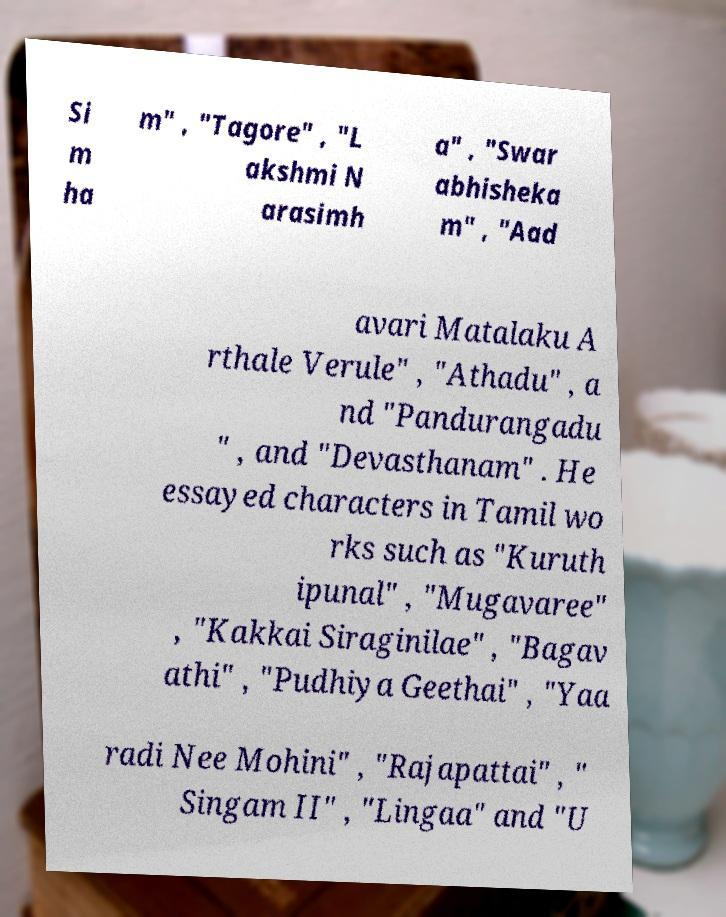I need the written content from this picture converted into text. Can you do that? Si m ha m" , "Tagore" , "L akshmi N arasimh a" , "Swar abhisheka m" , "Aad avari Matalaku A rthale Verule" , "Athadu" , a nd "Pandurangadu " , and "Devasthanam" . He essayed characters in Tamil wo rks such as "Kuruth ipunal" , "Mugavaree" , "Kakkai Siraginilae" , "Bagav athi" , "Pudhiya Geethai" , "Yaa radi Nee Mohini" , "Rajapattai" , " Singam II" , "Lingaa" and "U 